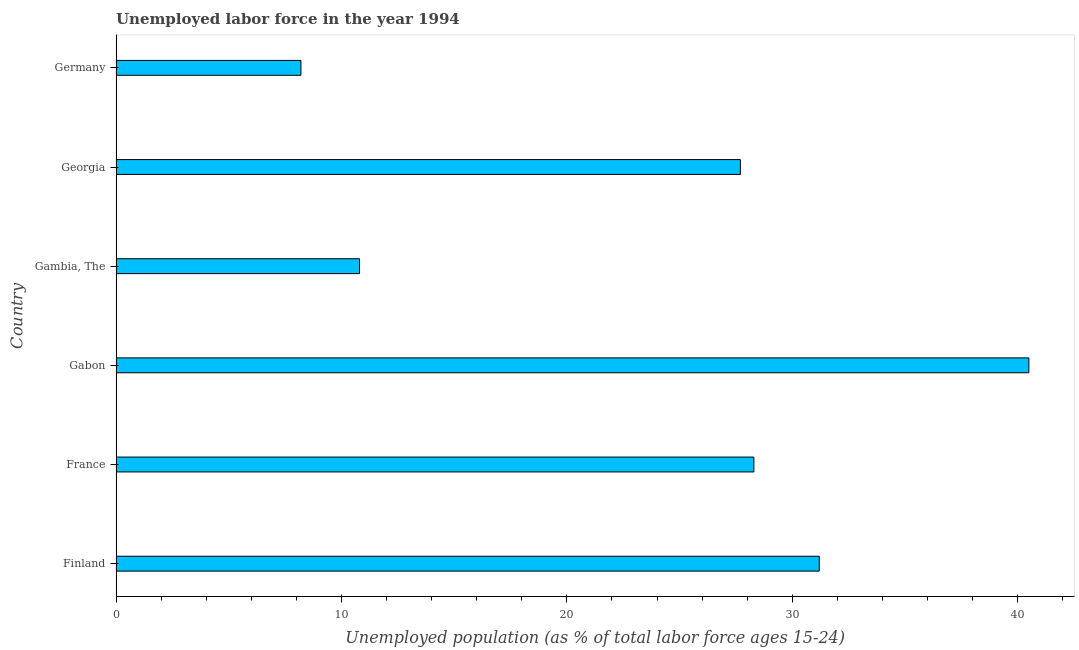Does the graph contain grids?
Make the answer very short. No. What is the title of the graph?
Keep it short and to the point. Unemployed labor force in the year 1994. What is the label or title of the X-axis?
Ensure brevity in your answer.  Unemployed population (as % of total labor force ages 15-24). What is the label or title of the Y-axis?
Ensure brevity in your answer.  Country. What is the total unemployed youth population in Gambia, The?
Offer a terse response. 10.8. Across all countries, what is the maximum total unemployed youth population?
Provide a succinct answer. 40.5. Across all countries, what is the minimum total unemployed youth population?
Offer a very short reply. 8.2. In which country was the total unemployed youth population maximum?
Your answer should be compact. Gabon. What is the sum of the total unemployed youth population?
Offer a very short reply. 146.7. What is the average total unemployed youth population per country?
Provide a short and direct response. 24.45. What is the median total unemployed youth population?
Your answer should be very brief. 28. In how many countries, is the total unemployed youth population greater than 28 %?
Provide a short and direct response. 3. What is the ratio of the total unemployed youth population in Finland to that in Gabon?
Provide a short and direct response. 0.77. Is the total unemployed youth population in Finland less than that in Germany?
Offer a very short reply. No. Is the difference between the total unemployed youth population in Georgia and Germany greater than the difference between any two countries?
Provide a succinct answer. No. What is the difference between the highest and the lowest total unemployed youth population?
Offer a terse response. 32.3. In how many countries, is the total unemployed youth population greater than the average total unemployed youth population taken over all countries?
Provide a short and direct response. 4. How many bars are there?
Ensure brevity in your answer.  6. Are all the bars in the graph horizontal?
Offer a very short reply. Yes. What is the difference between two consecutive major ticks on the X-axis?
Your answer should be very brief. 10. Are the values on the major ticks of X-axis written in scientific E-notation?
Give a very brief answer. No. What is the Unemployed population (as % of total labor force ages 15-24) in Finland?
Ensure brevity in your answer.  31.2. What is the Unemployed population (as % of total labor force ages 15-24) in France?
Ensure brevity in your answer.  28.3. What is the Unemployed population (as % of total labor force ages 15-24) of Gabon?
Keep it short and to the point. 40.5. What is the Unemployed population (as % of total labor force ages 15-24) in Gambia, The?
Your answer should be compact. 10.8. What is the Unemployed population (as % of total labor force ages 15-24) in Georgia?
Provide a short and direct response. 27.7. What is the Unemployed population (as % of total labor force ages 15-24) of Germany?
Your answer should be compact. 8.2. What is the difference between the Unemployed population (as % of total labor force ages 15-24) in Finland and France?
Give a very brief answer. 2.9. What is the difference between the Unemployed population (as % of total labor force ages 15-24) in Finland and Gabon?
Offer a terse response. -9.3. What is the difference between the Unemployed population (as % of total labor force ages 15-24) in Finland and Gambia, The?
Make the answer very short. 20.4. What is the difference between the Unemployed population (as % of total labor force ages 15-24) in France and Germany?
Provide a short and direct response. 20.1. What is the difference between the Unemployed population (as % of total labor force ages 15-24) in Gabon and Gambia, The?
Your response must be concise. 29.7. What is the difference between the Unemployed population (as % of total labor force ages 15-24) in Gabon and Germany?
Offer a terse response. 32.3. What is the difference between the Unemployed population (as % of total labor force ages 15-24) in Gambia, The and Georgia?
Ensure brevity in your answer.  -16.9. What is the difference between the Unemployed population (as % of total labor force ages 15-24) in Gambia, The and Germany?
Offer a terse response. 2.6. What is the difference between the Unemployed population (as % of total labor force ages 15-24) in Georgia and Germany?
Make the answer very short. 19.5. What is the ratio of the Unemployed population (as % of total labor force ages 15-24) in Finland to that in France?
Offer a terse response. 1.1. What is the ratio of the Unemployed population (as % of total labor force ages 15-24) in Finland to that in Gabon?
Ensure brevity in your answer.  0.77. What is the ratio of the Unemployed population (as % of total labor force ages 15-24) in Finland to that in Gambia, The?
Your answer should be very brief. 2.89. What is the ratio of the Unemployed population (as % of total labor force ages 15-24) in Finland to that in Georgia?
Provide a succinct answer. 1.13. What is the ratio of the Unemployed population (as % of total labor force ages 15-24) in Finland to that in Germany?
Give a very brief answer. 3.81. What is the ratio of the Unemployed population (as % of total labor force ages 15-24) in France to that in Gabon?
Keep it short and to the point. 0.7. What is the ratio of the Unemployed population (as % of total labor force ages 15-24) in France to that in Gambia, The?
Offer a terse response. 2.62. What is the ratio of the Unemployed population (as % of total labor force ages 15-24) in France to that in Georgia?
Provide a short and direct response. 1.02. What is the ratio of the Unemployed population (as % of total labor force ages 15-24) in France to that in Germany?
Make the answer very short. 3.45. What is the ratio of the Unemployed population (as % of total labor force ages 15-24) in Gabon to that in Gambia, The?
Your answer should be very brief. 3.75. What is the ratio of the Unemployed population (as % of total labor force ages 15-24) in Gabon to that in Georgia?
Your response must be concise. 1.46. What is the ratio of the Unemployed population (as % of total labor force ages 15-24) in Gabon to that in Germany?
Ensure brevity in your answer.  4.94. What is the ratio of the Unemployed population (as % of total labor force ages 15-24) in Gambia, The to that in Georgia?
Offer a terse response. 0.39. What is the ratio of the Unemployed population (as % of total labor force ages 15-24) in Gambia, The to that in Germany?
Provide a succinct answer. 1.32. What is the ratio of the Unemployed population (as % of total labor force ages 15-24) in Georgia to that in Germany?
Make the answer very short. 3.38. 